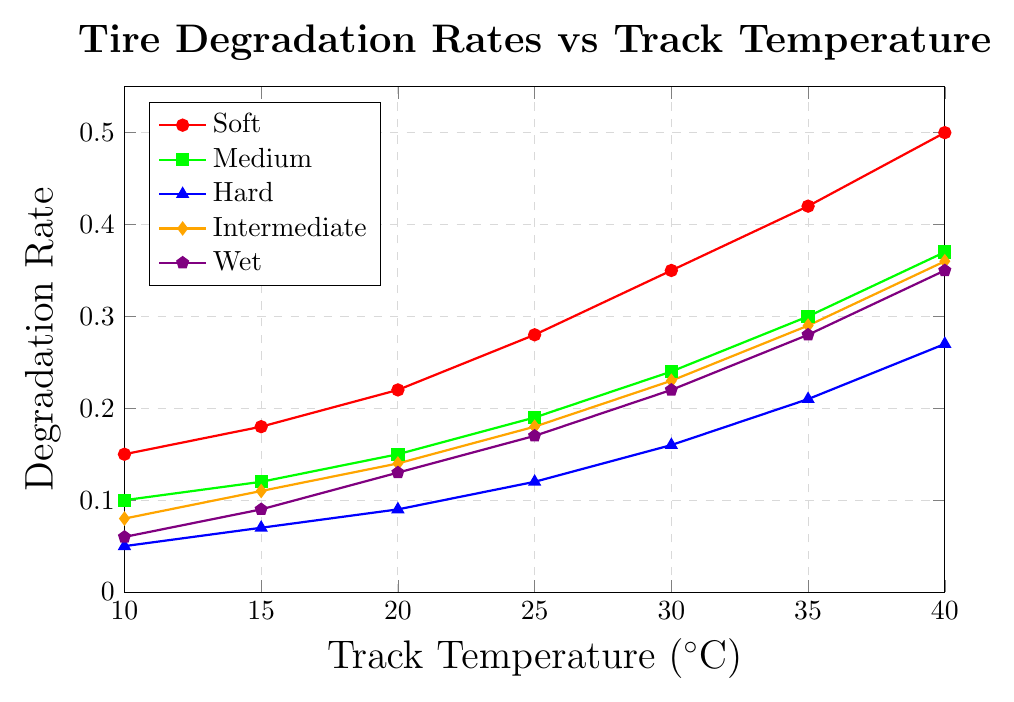What is the degradation rate of the Soft tire compound at 25°C? Locate the Soft tire compound line, which is represented by red, and find the corresponding degradation rate value at 25°C.
Answer: 0.28 Which tire compound has the highest degradation rate at 40°C? Compare the degradation rates of all tire compounds at 40°C. The Soft tire compound has the highest value.
Answer: Soft Between the Hard and Medium tire compounds, which one has a lower degradation rate at 15°C? Compare the degradation rates of the Hard and Medium tire compounds at 15°C. The Hard tire compound has a lower value.
Answer: Hard What is the average degradation rate of the Intermediate tire compound across all temperatures? Sum the degradation rates of the Intermediate tire compound at all given temperatures (0.08 + 0.11 + 0.14 + 0.18 + 0.23 + 0.29 + 0.36) and divide by the number of data points (7).
Answer: 0.197 How much does the degradation rate of the Wet tire compound increase from 10°C to 30°C? Subtract the degradation rate of the Wet tire compound at 10°C from its rate at 30°C (0.22 - 0.06).
Answer: 0.16 Which tire compound shows the steepest increase in degradation rate as the temperature rises from 20°C to 40°C? Calculate the difference in degradation rates between 20°C and 40°C for each tire compound. Compare the differences to identify the steepest increase. The Soft tire compound has the steepest increase (0.50 - 0.22).
Answer: Soft At what temperature does the degradation rate of the Medium tire compound cross 0.25? Locate the point on the Medium tire compound line where the degradation rate is closest to 0.25. The closest value is between 30°C and 35°C where it is 0.24 and 0.30.
Answer: Between 30°C and 35°C What is the difference in degradation rates between the Soft and Hard tire compounds at 20°C? Subtract the degradation rate of the Hard tire compound from the Soft tire compound at 20°C (0.22 - 0.09).
Answer: 0.13 Which tire compound has the lowest degradation rate at 30°C? Compare the degradation rates of all tire compounds at 30°C. The Hard tire compound has the lowest value.
Answer: Hard 